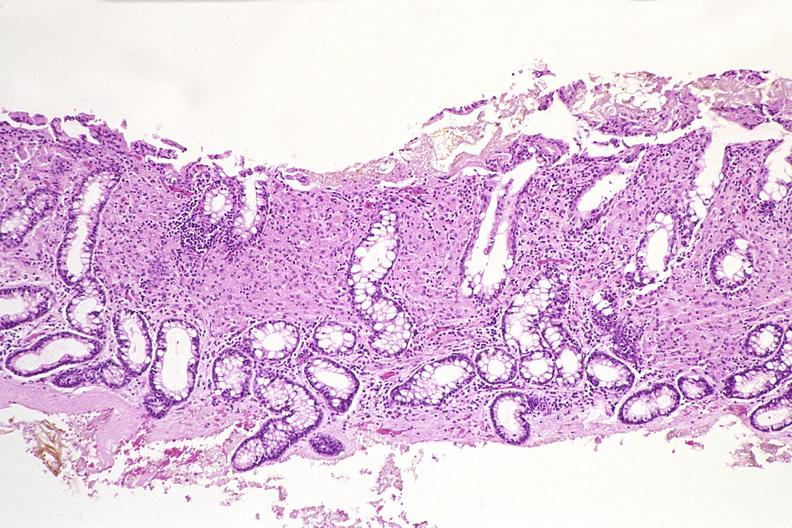s uterus present?
Answer the question using a single word or phrase. No 